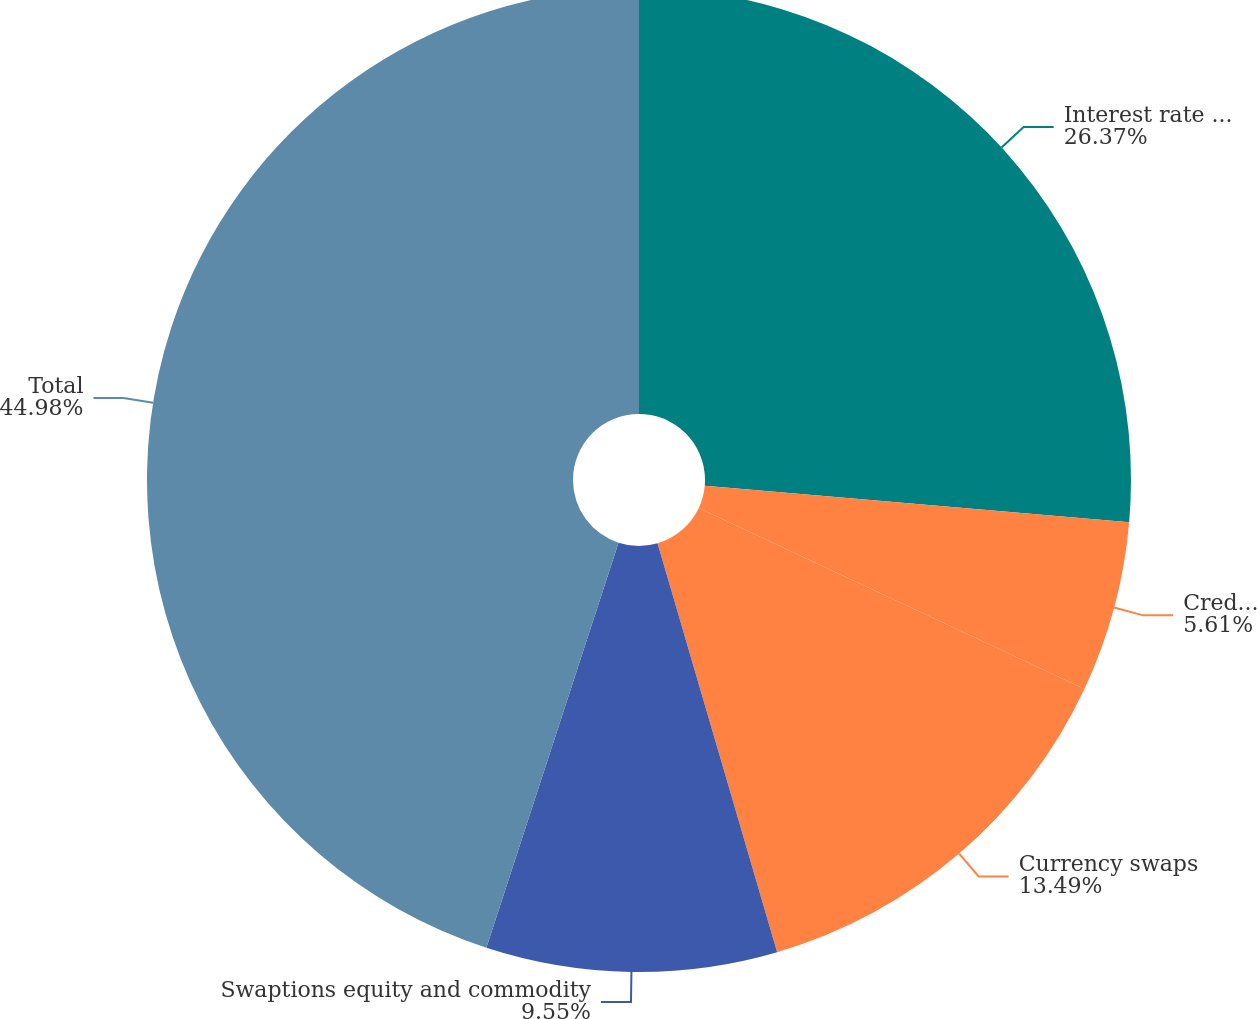Convert chart to OTSL. <chart><loc_0><loc_0><loc_500><loc_500><pie_chart><fcel>Interest rate swaps<fcel>Credit default swaps (b)<fcel>Currency swaps<fcel>Swaptions equity and commodity<fcel>Total<nl><fcel>26.37%<fcel>5.61%<fcel>13.49%<fcel>9.55%<fcel>44.98%<nl></chart> 